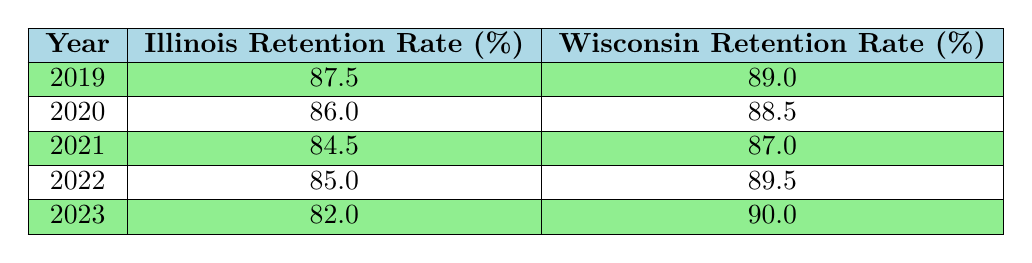What was the teacher retention rate in Illinois in 2020? The table lists retention rates for Illinois by year. For 2020, the retention rate is stated as 86.0%.
Answer: 86.0 What was the Wisconsin retention rate in 2023? According to the table, the Wisconsin retention rate for the year 2023 is 90.0%.
Answer: 90.0 Which state's retention rate was higher in 2021? In 2021, Illinois had a retention rate of 84.5%, and Wisconsin had a retention rate of 87.0%. Since 87.0% is greater than 84.5%, Wisconsin's retention rate was higher.
Answer: Wisconsin What is the difference in retention rates between Illinois and Wisconsin in 2019? For the year 2019, Illinois had a retention rate of 87.5% and Wisconsin had a retention rate of 89.0%. The difference is calculated by subtracting Illinois's rate from Wisconsin's, which is 89.0% - 87.5% = 1.5%.
Answer: 1.5 What is the average retention rate for Illinois over the five years? To find the average, sum the retention rates: 87.5 + 86.0 + 84.5 + 85.0 + 82.0 = 425.0. Then divide by the number of years (5): 425.0 / 5 = 85.0. Thus, the average retention rate is 85.0%.
Answer: 85.0 Was there a decrease in the retention rate for Illinois from 2019 to 2023? In 2019, the rate was 87.5%, and in 2023 it fell to 82.0%. Since 82.0% is less than 87.5%, it confirms that there was indeed a decrease over this period.
Answer: Yes In which year did Illinois have the lowest retention rate? By examining the rates in the table for Illinois from 2019 to 2023, we see the lowest figure is 82.0% in 2023. This is the lowest recorded rate in the provided data.
Answer: 2023 What was the overall trend in retention rates for Wisconsin from 2019 to 2023? Observing the rates, Wisconsin’s retention rates increased from 89.0% in 2019 to 90.0% in 2023. This shows a consistent upward trend over the five years.
Answer: Increase Which year had the highest retention rate for Wisconsin? The highest reported retention rate for Wisconsin is 90.0%, which occurred in the year 2023. Therefore, 2023 is the year with the highest rate.
Answer: 2023 